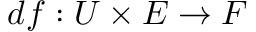<formula> <loc_0><loc_0><loc_500><loc_500>d f \colon U \times E \to F</formula> 